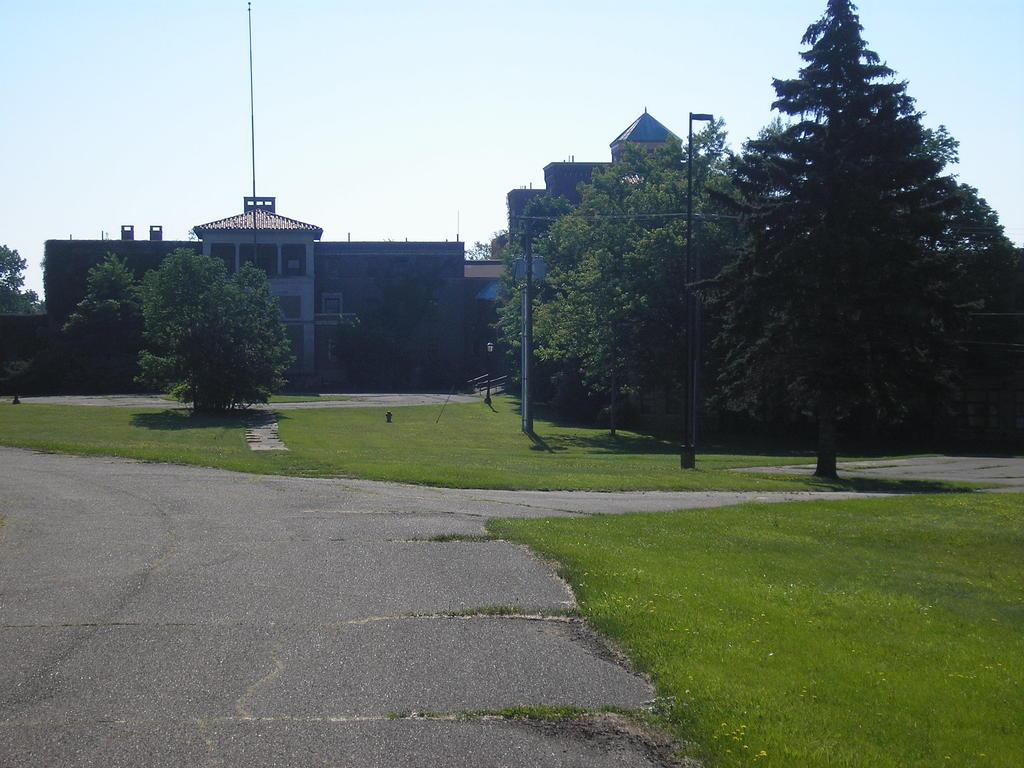What type of structures can be seen in the image? There are buildings in the image. What is located in front of the buildings? Trees are present in front of the buildings. What type of lighting is visible in the image? Lamp posts are visible in the image. What type of surface is present in the image? There is grass on the surface in the image. What type of pathway is present in the image? There is a road in the image. What type of linen is draped over the trees in the image? There is no linen draped over the trees in the image; the trees are not covered by any fabric. 